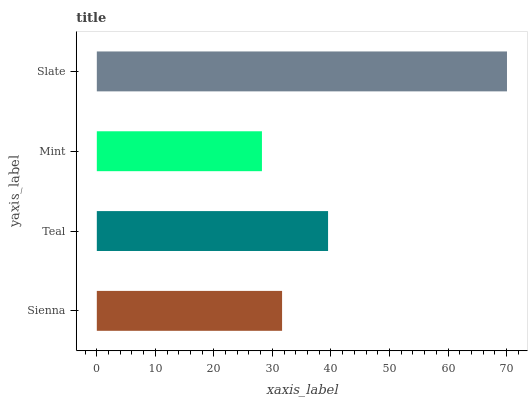Is Mint the minimum?
Answer yes or no. Yes. Is Slate the maximum?
Answer yes or no. Yes. Is Teal the minimum?
Answer yes or no. No. Is Teal the maximum?
Answer yes or no. No. Is Teal greater than Sienna?
Answer yes or no. Yes. Is Sienna less than Teal?
Answer yes or no. Yes. Is Sienna greater than Teal?
Answer yes or no. No. Is Teal less than Sienna?
Answer yes or no. No. Is Teal the high median?
Answer yes or no. Yes. Is Sienna the low median?
Answer yes or no. Yes. Is Mint the high median?
Answer yes or no. No. Is Mint the low median?
Answer yes or no. No. 